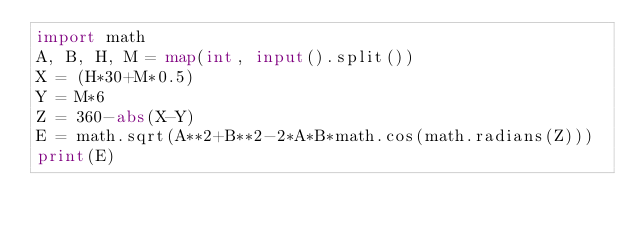<code> <loc_0><loc_0><loc_500><loc_500><_Python_>import math
A, B, H, M = map(int, input().split())
X = (H*30+M*0.5)
Y = M*6
Z = 360-abs(X-Y)
E = math.sqrt(A**2+B**2-2*A*B*math.cos(math.radians(Z)))
print(E)</code> 